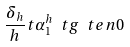<formula> <loc_0><loc_0><loc_500><loc_500>\frac { \delta _ { h } } { h } t \alpha ^ { h } _ { 1 } \ t g \ t e n 0</formula> 